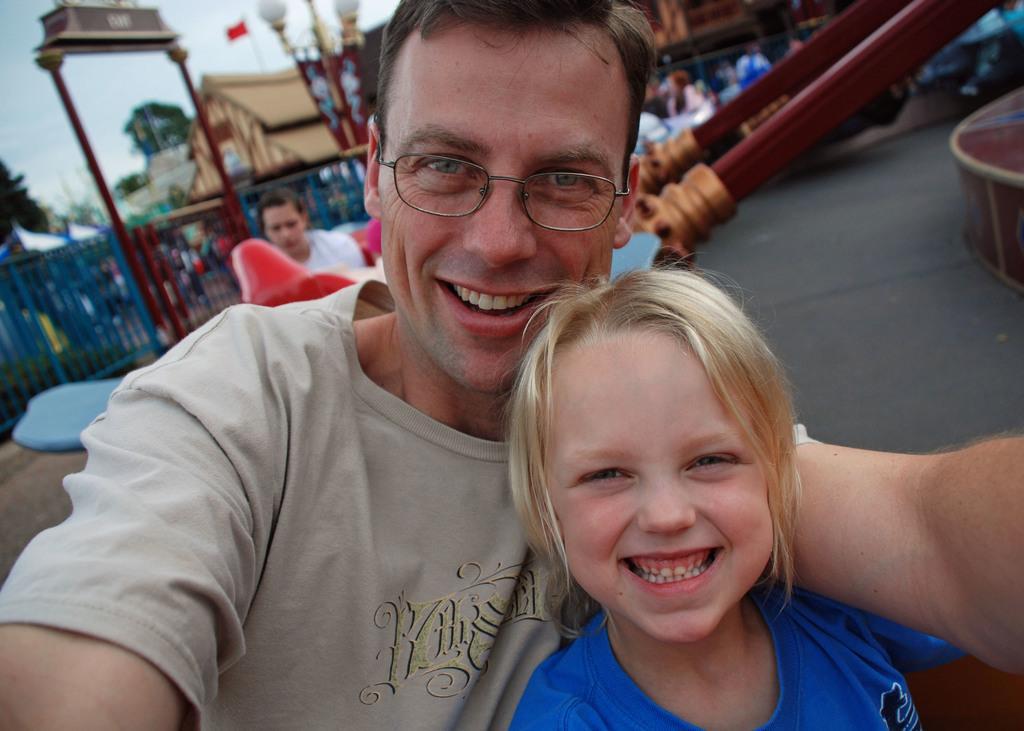In one or two sentences, can you explain what this image depicts? This picture describes about group of people, in the middle of the image we can see a girl and a man, they both are smiling and he wore spectacles, in the background we can see few buildings, trees and fence, and also we can see few lights. 